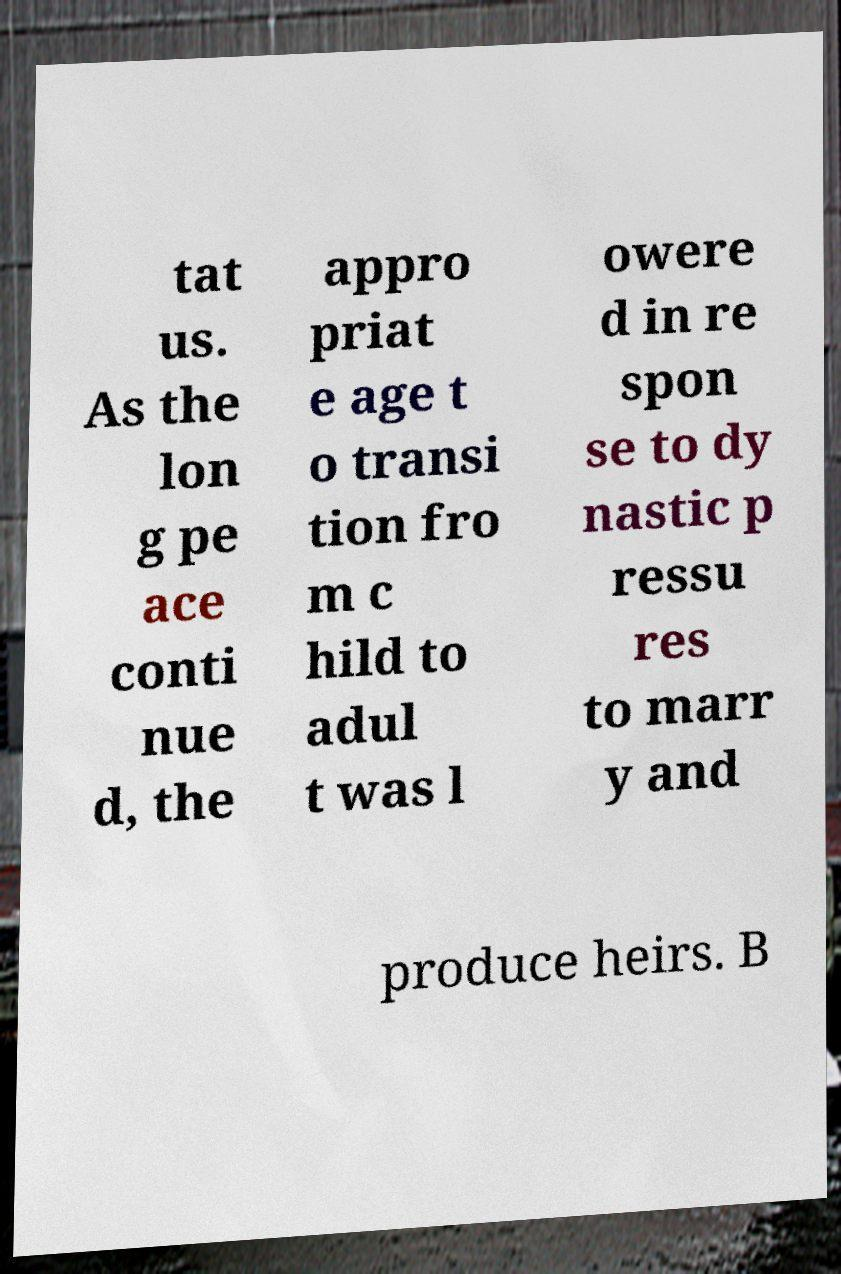For documentation purposes, I need the text within this image transcribed. Could you provide that? tat us. As the lon g pe ace conti nue d, the appro priat e age t o transi tion fro m c hild to adul t was l owere d in re spon se to dy nastic p ressu res to marr y and produce heirs. B 